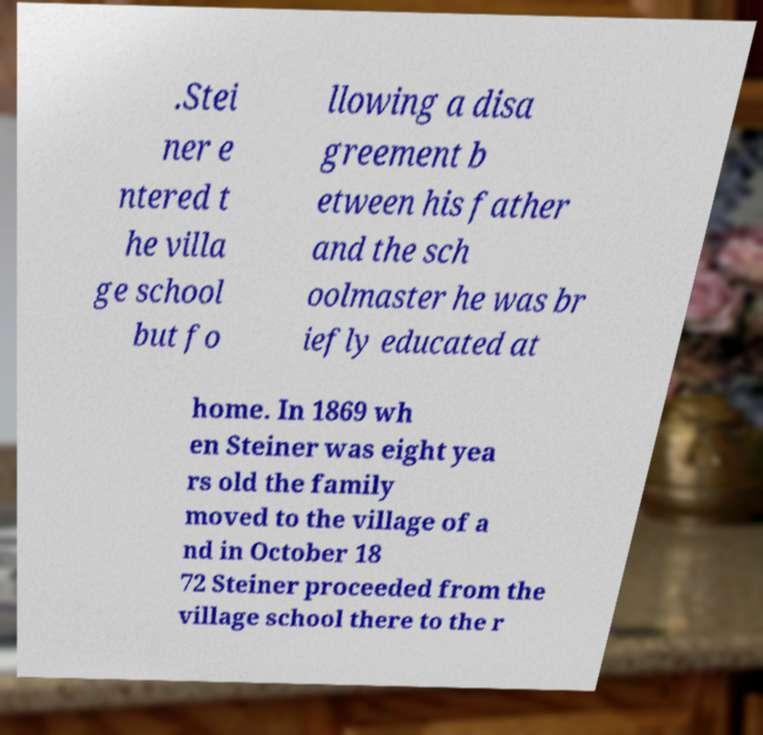What messages or text are displayed in this image? I need them in a readable, typed format. .Stei ner e ntered t he villa ge school but fo llowing a disa greement b etween his father and the sch oolmaster he was br iefly educated at home. In 1869 wh en Steiner was eight yea rs old the family moved to the village of a nd in October 18 72 Steiner proceeded from the village school there to the r 